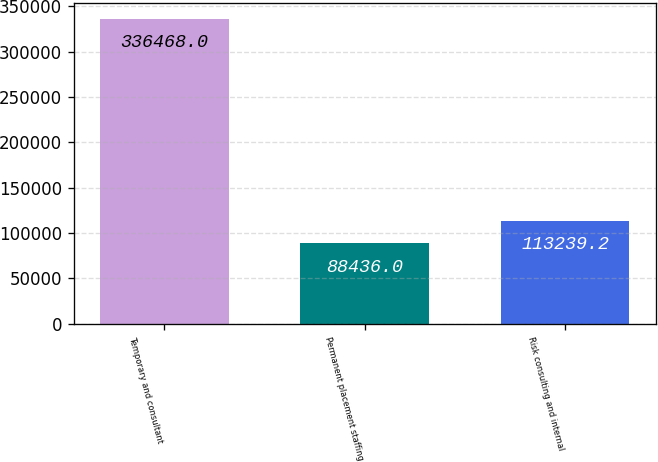Convert chart to OTSL. <chart><loc_0><loc_0><loc_500><loc_500><bar_chart><fcel>Temporary and consultant<fcel>Permanent placement staffing<fcel>Risk consulting and internal<nl><fcel>336468<fcel>88436<fcel>113239<nl></chart> 